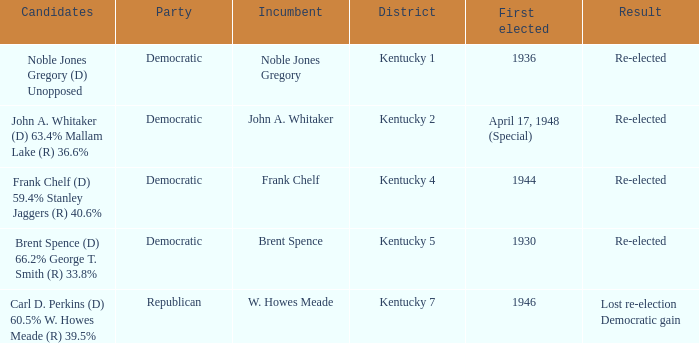What was the result of the election incumbent Brent Spence took place in? Re-elected. Can you give me this table as a dict? {'header': ['Candidates', 'Party', 'Incumbent', 'District', 'First elected', 'Result'], 'rows': [['Noble Jones Gregory (D) Unopposed', 'Democratic', 'Noble Jones Gregory', 'Kentucky 1', '1936', 'Re-elected'], ['John A. Whitaker (D) 63.4% Mallam Lake (R) 36.6%', 'Democratic', 'John A. Whitaker', 'Kentucky 2', 'April 17, 1948 (Special)', 'Re-elected'], ['Frank Chelf (D) 59.4% Stanley Jaggers (R) 40.6%', 'Democratic', 'Frank Chelf', 'Kentucky 4', '1944', 'Re-elected'], ['Brent Spence (D) 66.2% George T. Smith (R) 33.8%', 'Democratic', 'Brent Spence', 'Kentucky 5', '1930', 'Re-elected'], ['Carl D. Perkins (D) 60.5% W. Howes Meade (R) 39.5%', 'Republican', 'W. Howes Meade', 'Kentucky 7', '1946', 'Lost re-election Democratic gain']]} 